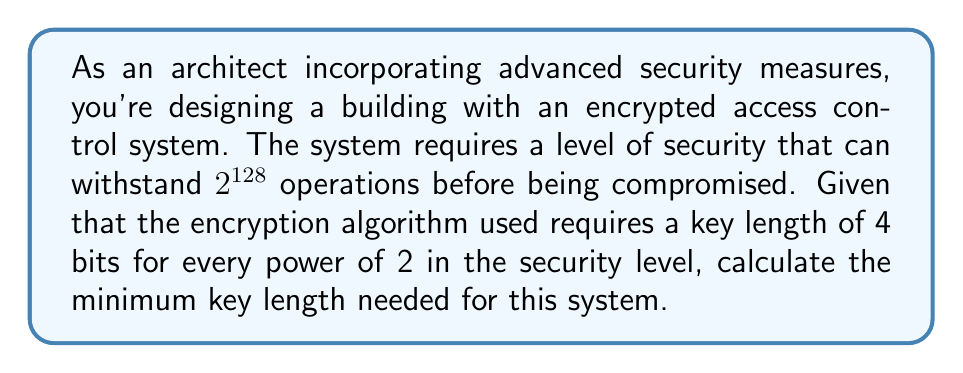Can you answer this question? To solve this problem, we'll follow these steps:

1) The security level is given as $2^{128}$ operations.

2) We need to find the power of 2 that corresponds to this security level:
   $2^{128} = (2^2)^{64} = 4^{64}$

3) The question states that the encryption algorithm requires 4 bits of key length for every power of 2 in the security level.

4) We found that the security level is equivalent to $4^{64}$, which means there are 64 powers of 2.

5) Therefore, the key length required is:
   $\text{Key Length} = 64 \times 4 = 256$ bits

This means that to achieve a security level that can withstand $2^{128}$ operations, we need an encryption key that is 256 bits long.
Answer: 256 bits 